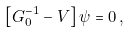<formula> <loc_0><loc_0><loc_500><loc_500>\left [ G _ { 0 } ^ { - 1 } - V \right ] \psi = 0 \, ,</formula> 